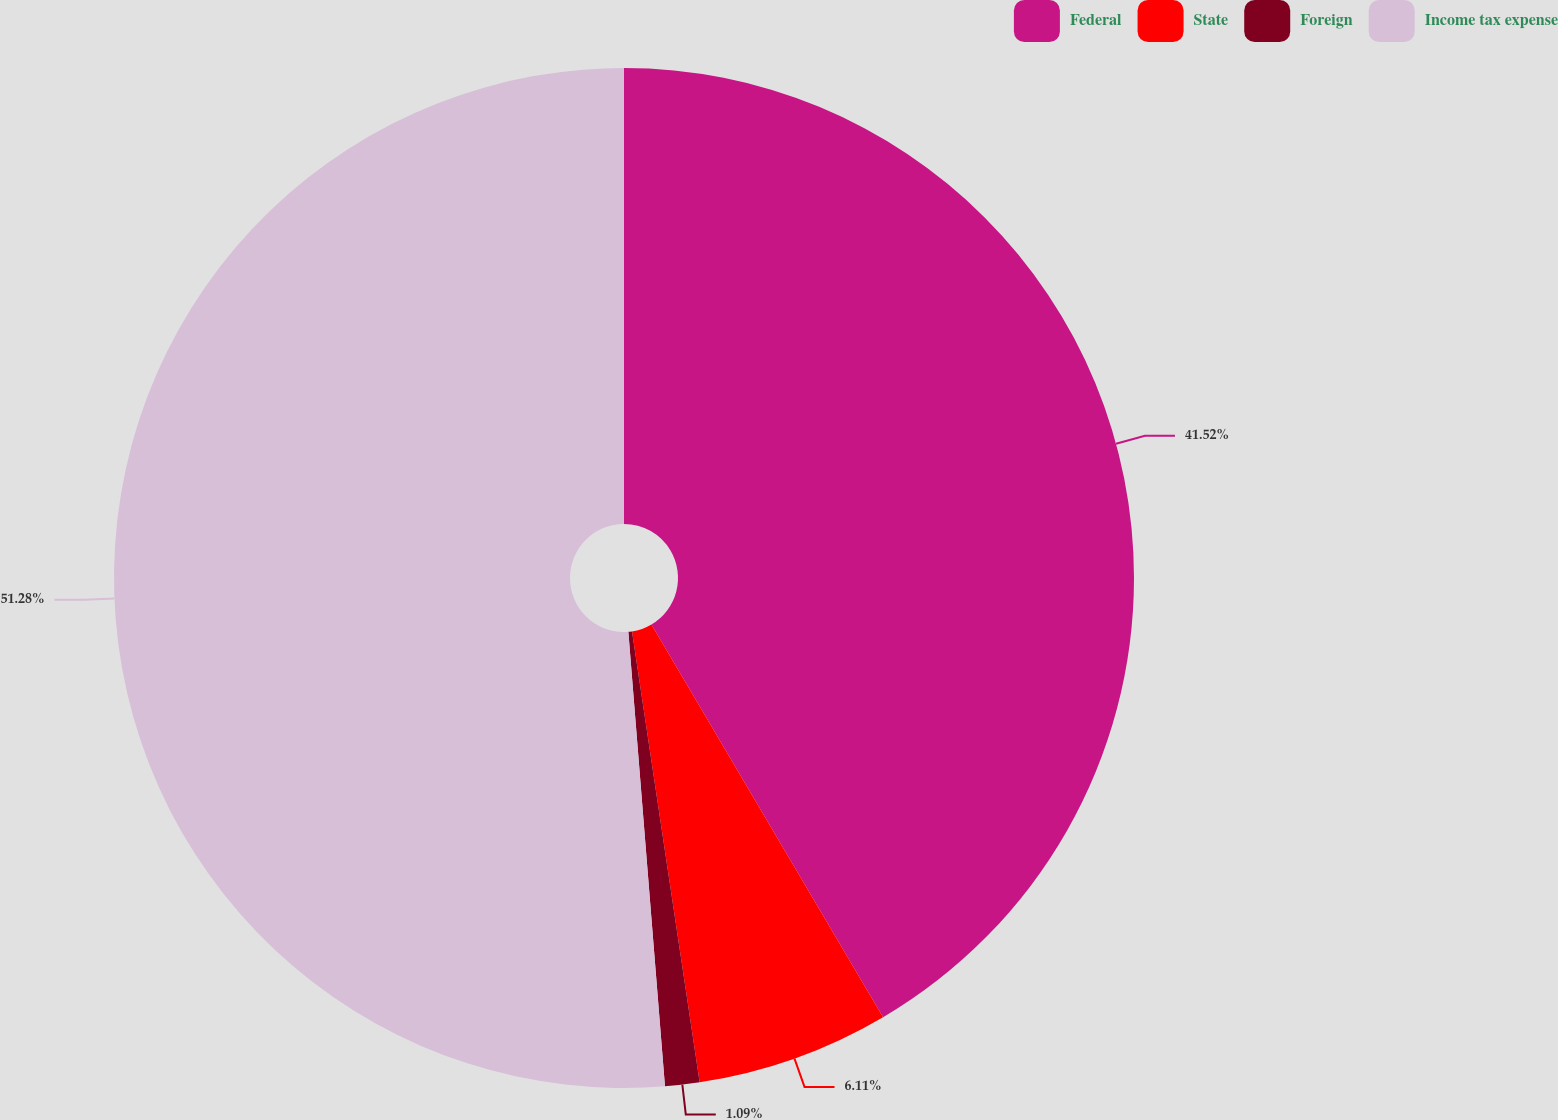Convert chart to OTSL. <chart><loc_0><loc_0><loc_500><loc_500><pie_chart><fcel>Federal<fcel>State<fcel>Foreign<fcel>Income tax expense<nl><fcel>41.52%<fcel>6.11%<fcel>1.09%<fcel>51.28%<nl></chart> 